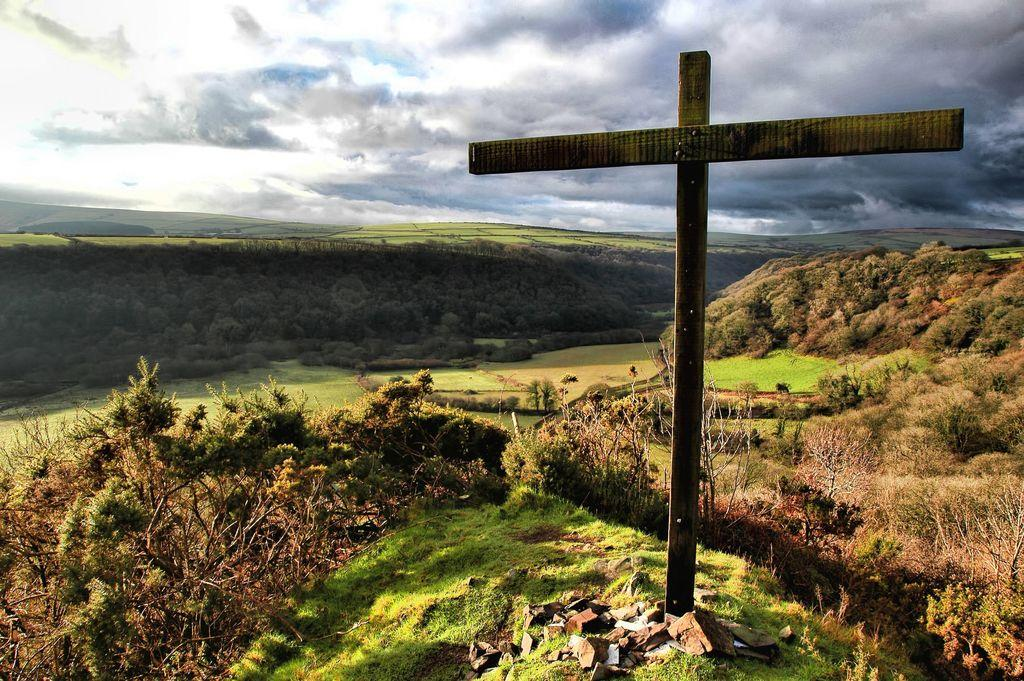What is the shape of the wooden sticks in the image? The wooden sticks are arranged in the shape of a cross in the image. What type of cross is depicted by the wooden sticks? The wooden sticks are arranged in the shape of a christ cross. What type of vegetation can be seen in the image? There is grass, plants, and trees in the image. What color is the church in the image? There is no church present in the image; it features wooden sticks arranged in the shape of a christ cross and various types of vegetation. 